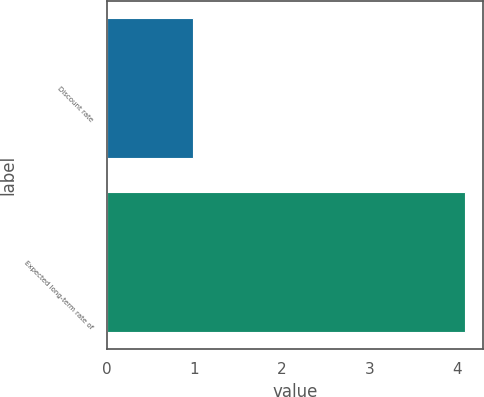Convert chart. <chart><loc_0><loc_0><loc_500><loc_500><bar_chart><fcel>Discount rate<fcel>Expected long-term rate of<nl><fcel>0.98<fcel>4.09<nl></chart> 